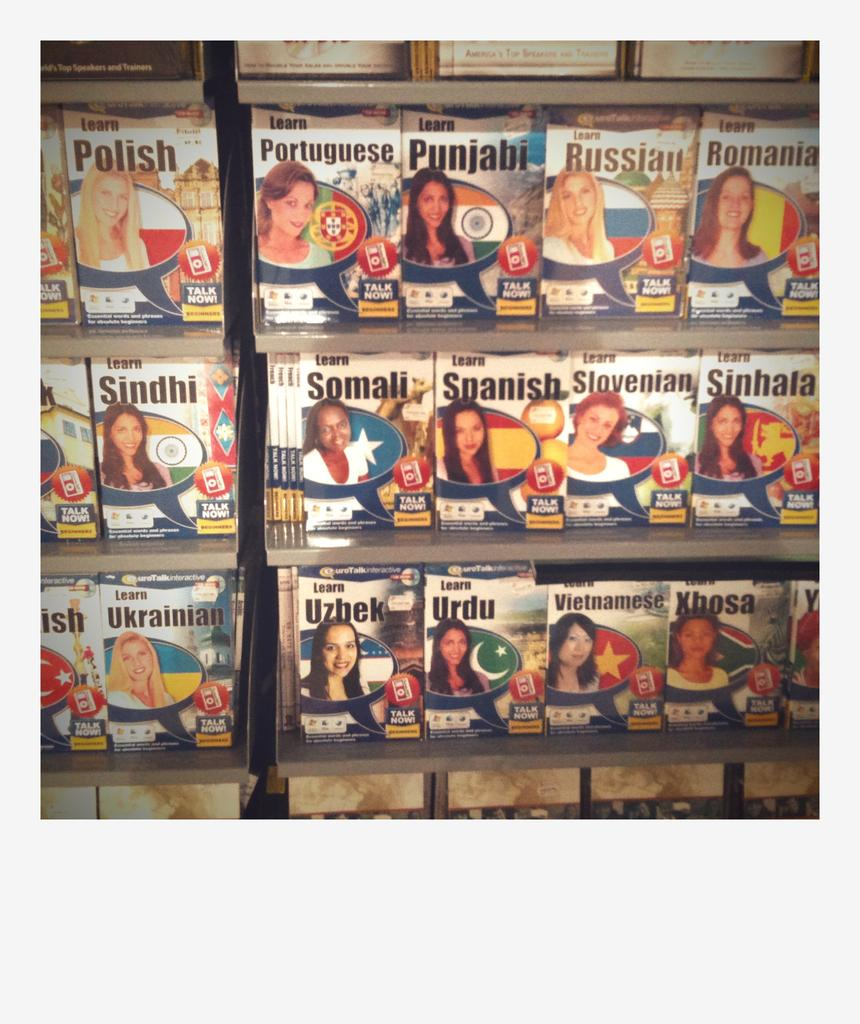<image>
Write a terse but informative summary of the picture. A wall of language learning software including Somali and Spanish. 